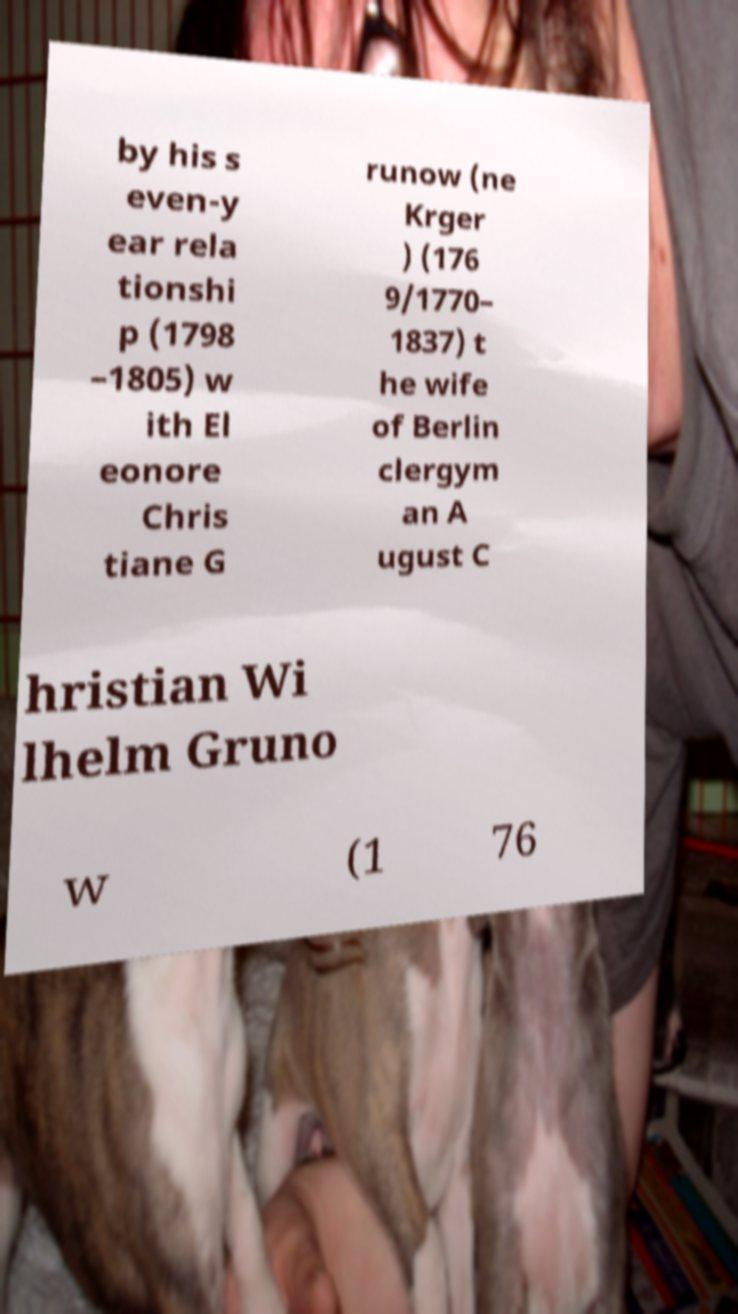Can you read and provide the text displayed in the image?This photo seems to have some interesting text. Can you extract and type it out for me? by his s even-y ear rela tionshi p (1798 –1805) w ith El eonore Chris tiane G runow (ne Krger ) (176 9/1770– 1837) t he wife of Berlin clergym an A ugust C hristian Wi lhelm Gruno w (1 76 